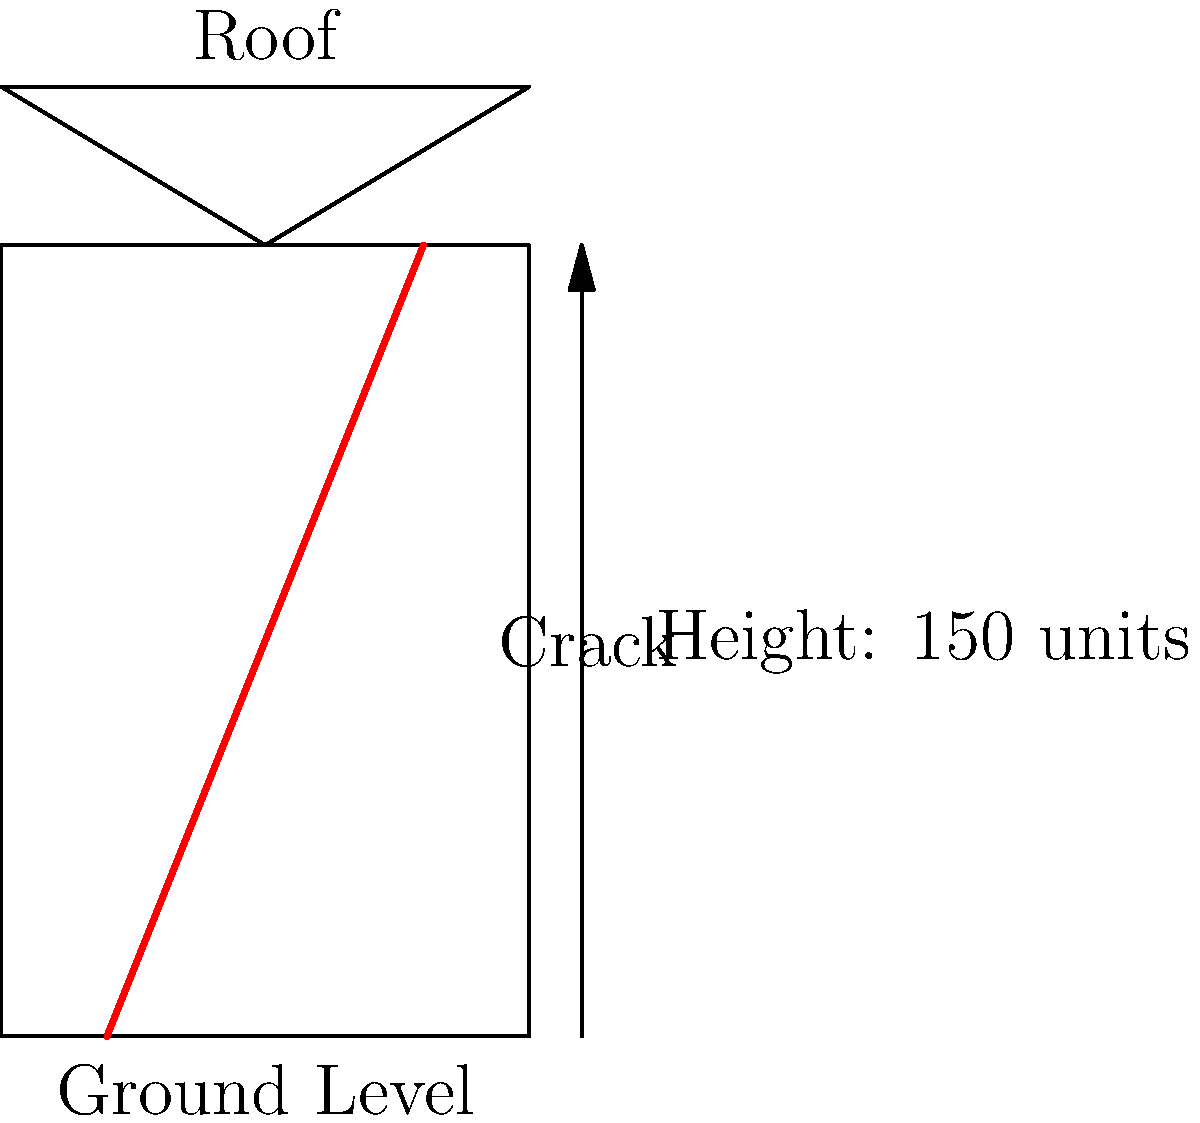In the aftermath of the 2010 Haiti earthquake, you're assessing building damage. The cross-sectional diagram shows a structure with a significant crack. If the building is 150 units tall and the crack extends from the ground to the roof at an average angle of $\theta$ degrees from vertical, what is the approximate horizontal displacement $d$ at the top of the building? Use the formula $d = 150 \tan(\theta)$ and assume $\theta = 20°$. To solve this problem, we'll follow these steps:

1. Identify the given information:
   - Building height = 150 units
   - Crack angle $\theta = 20°$
   - Formula: $d = 150 \tan(\theta)$

2. Understand the formula:
   - $d$ represents the horizontal displacement at the top of the building
   - $150$ is the height of the building
   - $\tan(\theta)$ is the tangent of the angle of the crack

3. Calculate the tangent of 20°:
   $\tan(20°) \approx 0.3640$

4. Apply the formula:
   $d = 150 \tan(20°)$
   $d = 150 \times 0.3640$
   $d = 54.60$ units

5. Round to a reasonable number of significant figures:
   $d \approx 55$ units

This result indicates that the top of the building has shifted horizontally by approximately 55 units due to the crack, which is a significant displacement relative to the building's height. This analysis helps in assessing the structural integrity and potential risks associated with the damaged building.
Answer: 55 units 